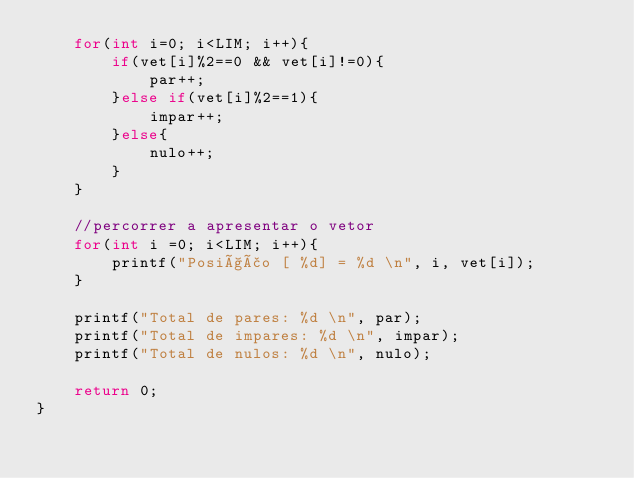<code> <loc_0><loc_0><loc_500><loc_500><_C_>    for(int i=0; i<LIM; i++){
        if(vet[i]%2==0 && vet[i]!=0){
            par++;
        }else if(vet[i]%2==1){
            impar++;
        }else{
            nulo++;
        }
    }

    //percorrer a apresentar o vetor
    for(int i =0; i<LIM; i++){
        printf("Posição [ %d] = %d \n", i, vet[i]);
    }

    printf("Total de pares: %d \n", par);
    printf("Total de impares: %d \n", impar);
    printf("Total de nulos: %d \n", nulo);

    return 0;
}
</code> 